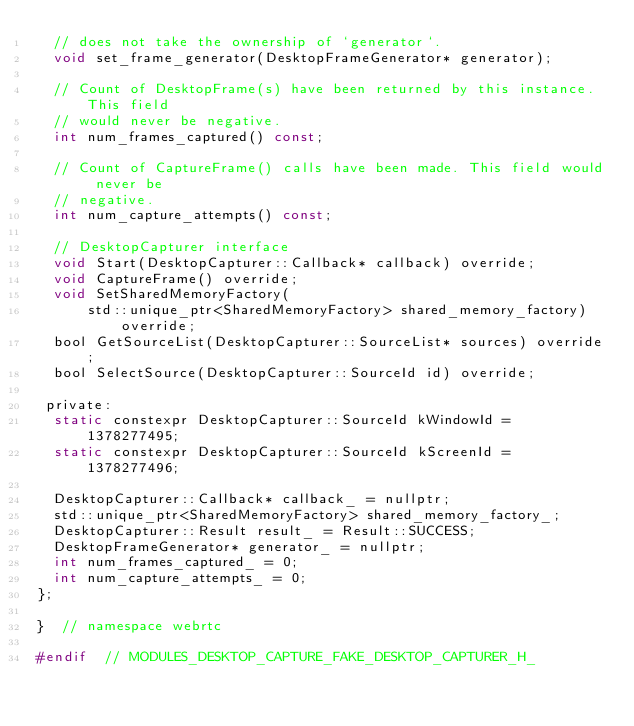Convert code to text. <code><loc_0><loc_0><loc_500><loc_500><_C_>  // does not take the ownership of `generator`.
  void set_frame_generator(DesktopFrameGenerator* generator);

  // Count of DesktopFrame(s) have been returned by this instance. This field
  // would never be negative.
  int num_frames_captured() const;

  // Count of CaptureFrame() calls have been made. This field would never be
  // negative.
  int num_capture_attempts() const;

  // DesktopCapturer interface
  void Start(DesktopCapturer::Callback* callback) override;
  void CaptureFrame() override;
  void SetSharedMemoryFactory(
      std::unique_ptr<SharedMemoryFactory> shared_memory_factory) override;
  bool GetSourceList(DesktopCapturer::SourceList* sources) override;
  bool SelectSource(DesktopCapturer::SourceId id) override;

 private:
  static constexpr DesktopCapturer::SourceId kWindowId = 1378277495;
  static constexpr DesktopCapturer::SourceId kScreenId = 1378277496;

  DesktopCapturer::Callback* callback_ = nullptr;
  std::unique_ptr<SharedMemoryFactory> shared_memory_factory_;
  DesktopCapturer::Result result_ = Result::SUCCESS;
  DesktopFrameGenerator* generator_ = nullptr;
  int num_frames_captured_ = 0;
  int num_capture_attempts_ = 0;
};

}  // namespace webrtc

#endif  // MODULES_DESKTOP_CAPTURE_FAKE_DESKTOP_CAPTURER_H_
</code> 